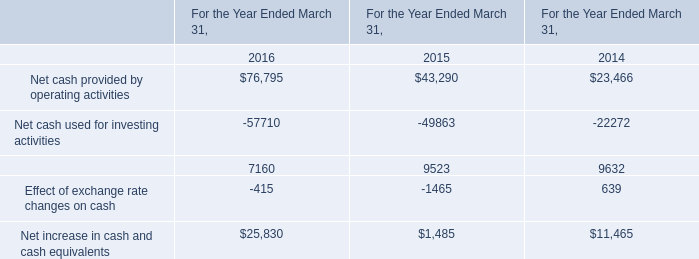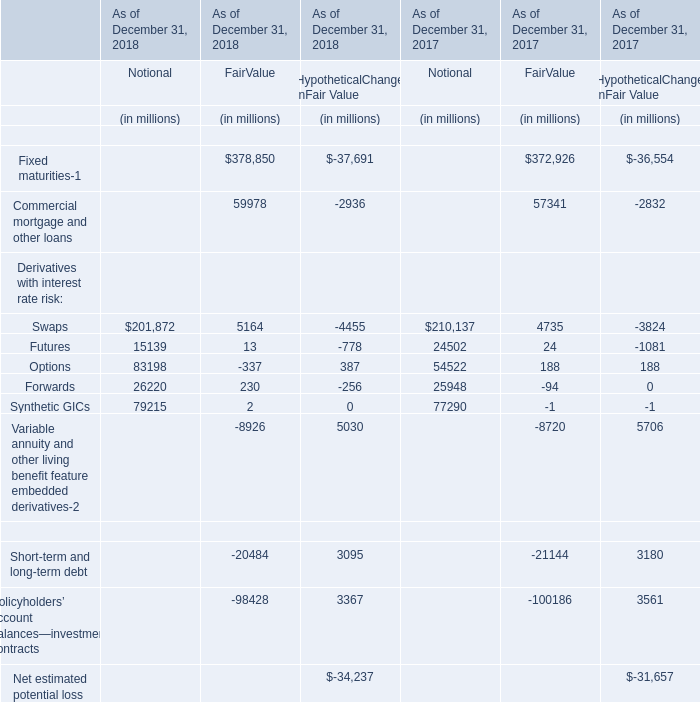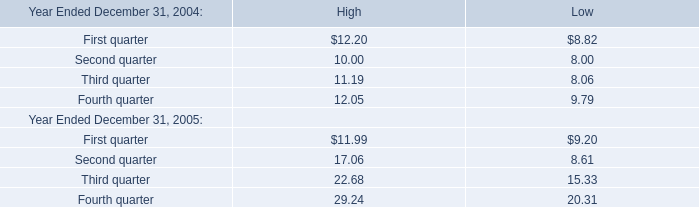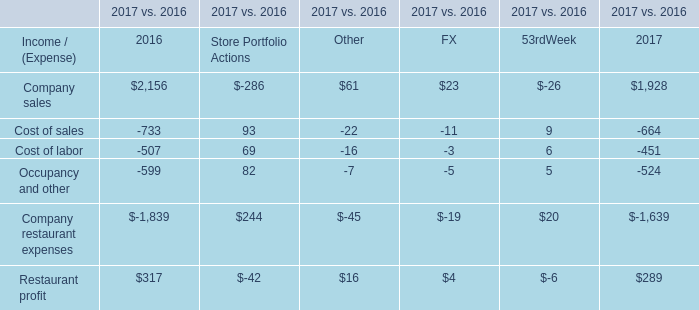What was the total amount of Notional greater than 80000 in 2018? (in million) 
Computations: (201872 + 83198)
Answer: 285070.0. 